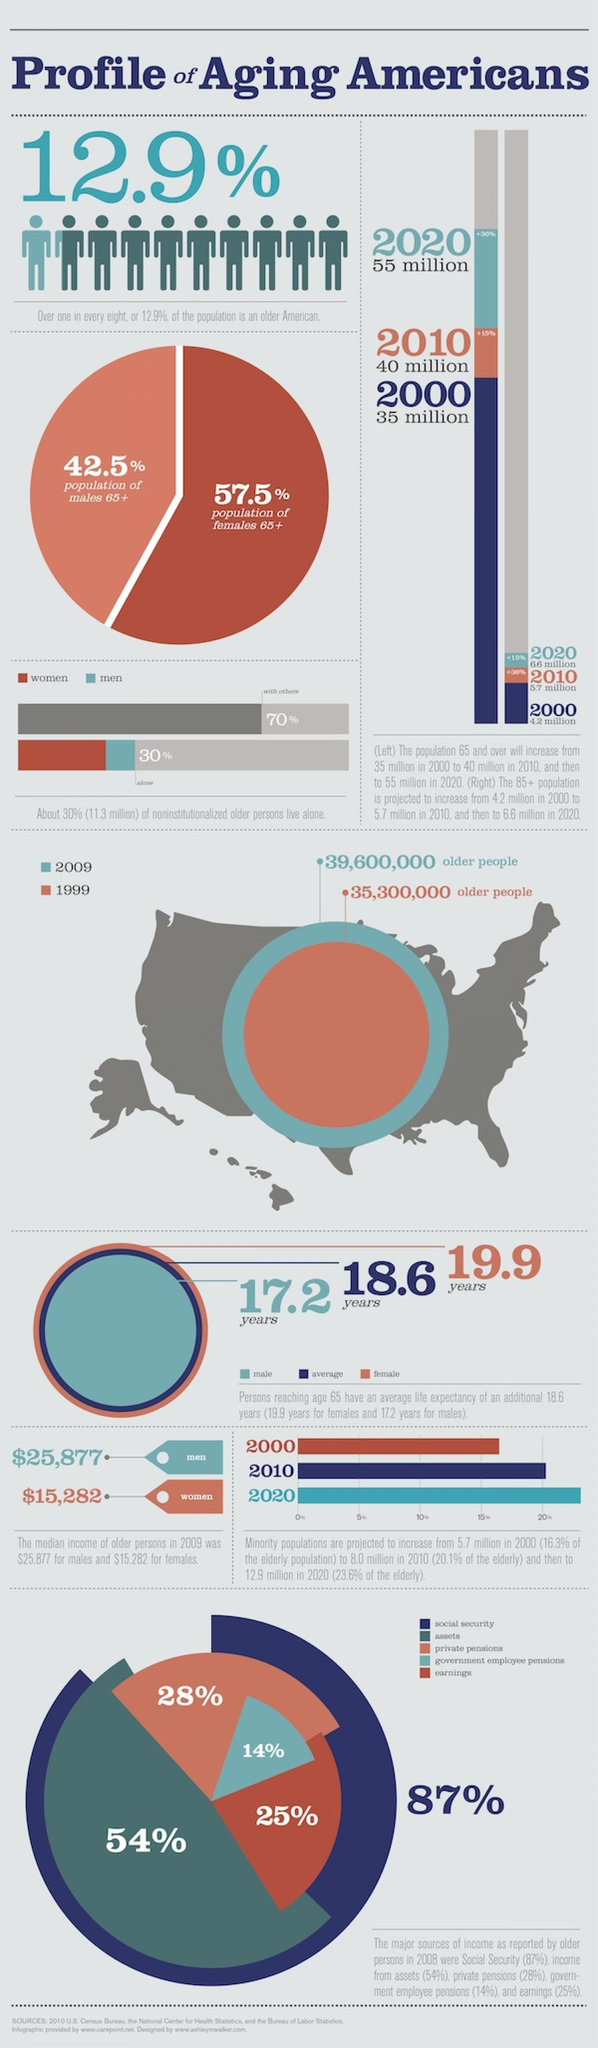What is the percentage of earnings and assets, taken together?
Answer the question with a short phrase. 79% What is the percentage of social security and assets, taken together? 141% 